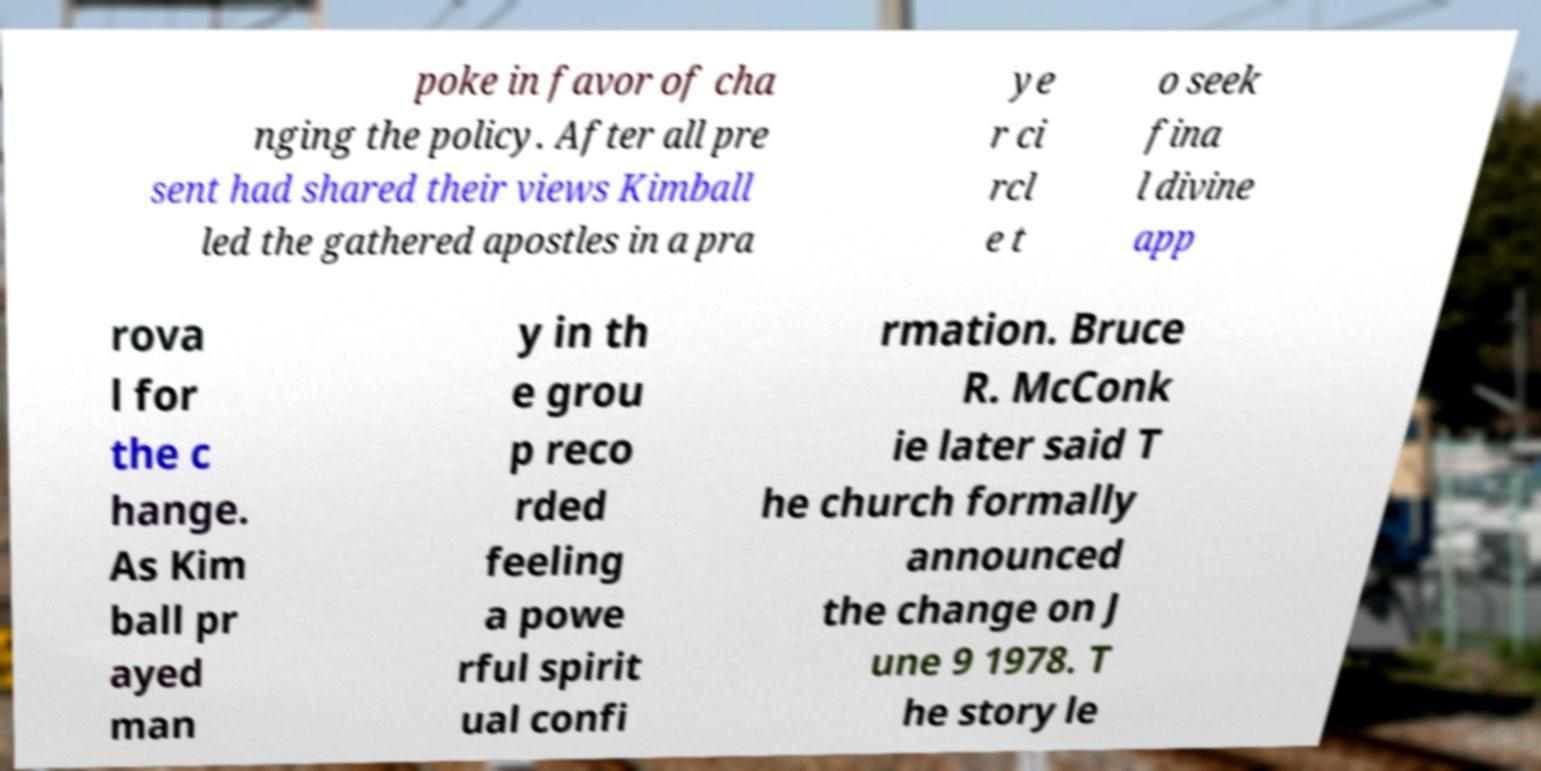Can you read and provide the text displayed in the image?This photo seems to have some interesting text. Can you extract and type it out for me? poke in favor of cha nging the policy. After all pre sent had shared their views Kimball led the gathered apostles in a pra ye r ci rcl e t o seek fina l divine app rova l for the c hange. As Kim ball pr ayed man y in th e grou p reco rded feeling a powe rful spirit ual confi rmation. Bruce R. McConk ie later said T he church formally announced the change on J une 9 1978. T he story le 